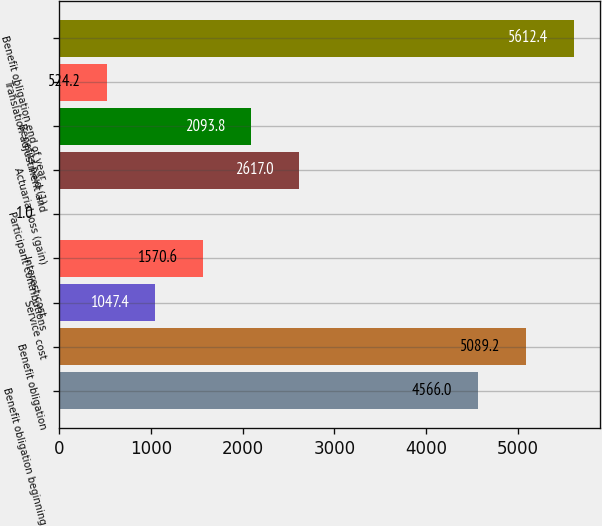Convert chart. <chart><loc_0><loc_0><loc_500><loc_500><bar_chart><fcel>Benefit obligation beginning<fcel>Benefit obligation<fcel>Service cost<fcel>Interest cost<fcel>Participant contributions<fcel>Actuarial loss (gain)<fcel>Benefits paid (1)<fcel>Translation adjustment and<fcel>Benefit obligation end of year<nl><fcel>4566<fcel>5089.2<fcel>1047.4<fcel>1570.6<fcel>1<fcel>2617<fcel>2093.8<fcel>524.2<fcel>5612.4<nl></chart> 